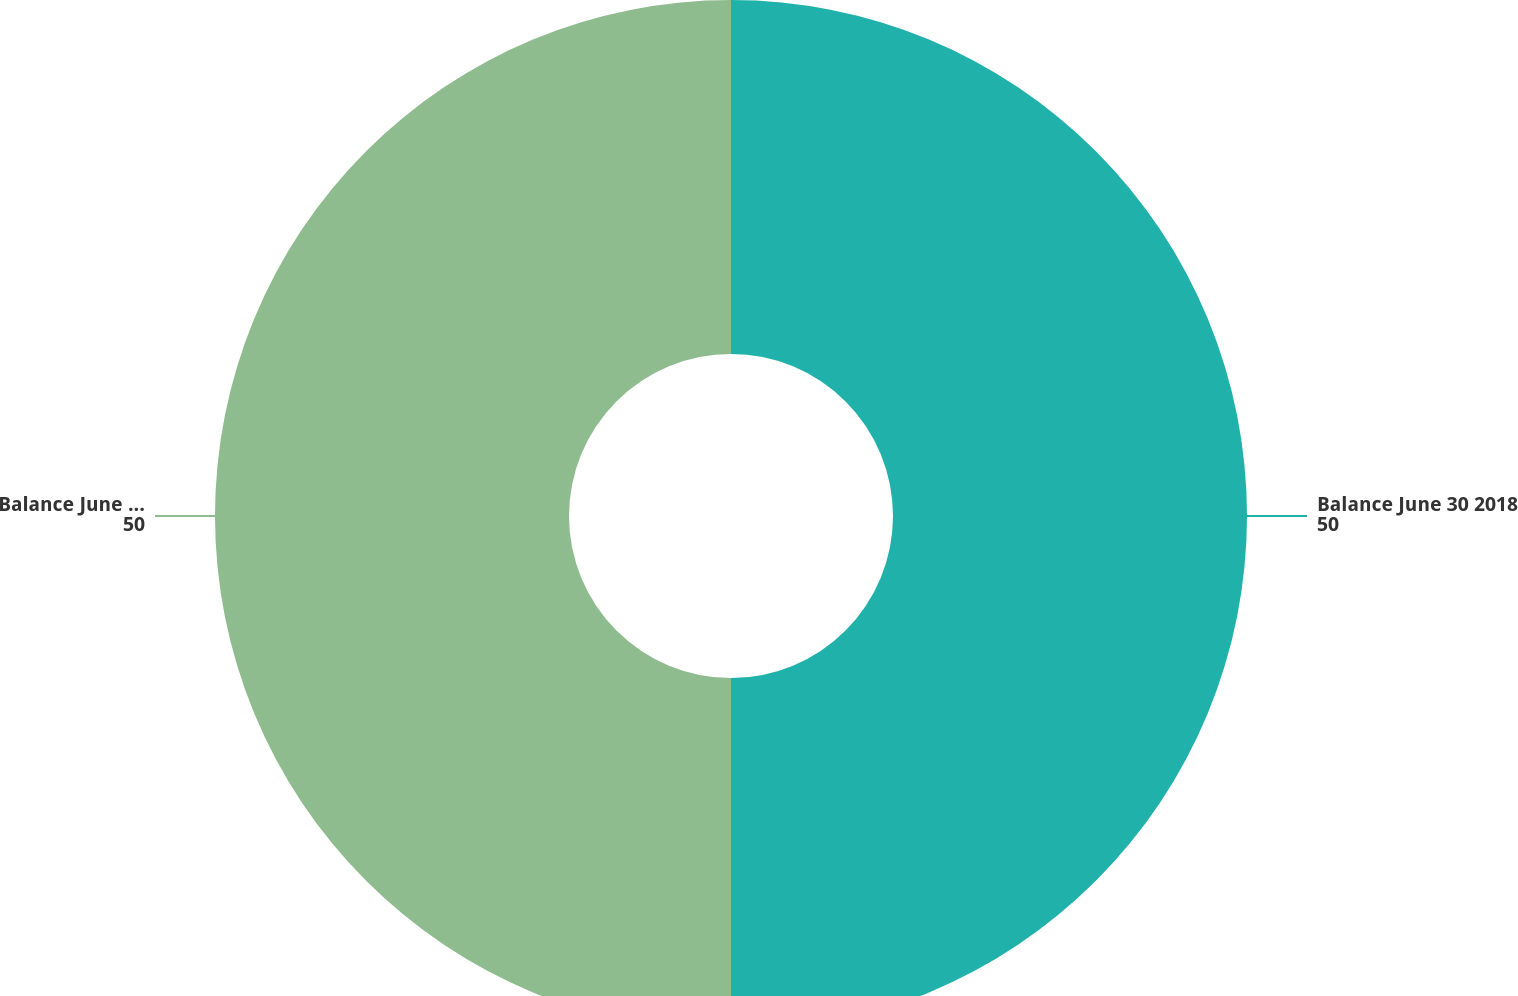<chart> <loc_0><loc_0><loc_500><loc_500><pie_chart><fcel>Balance June 30 2018<fcel>Balance June 30 2019<nl><fcel>50.0%<fcel>50.0%<nl></chart> 